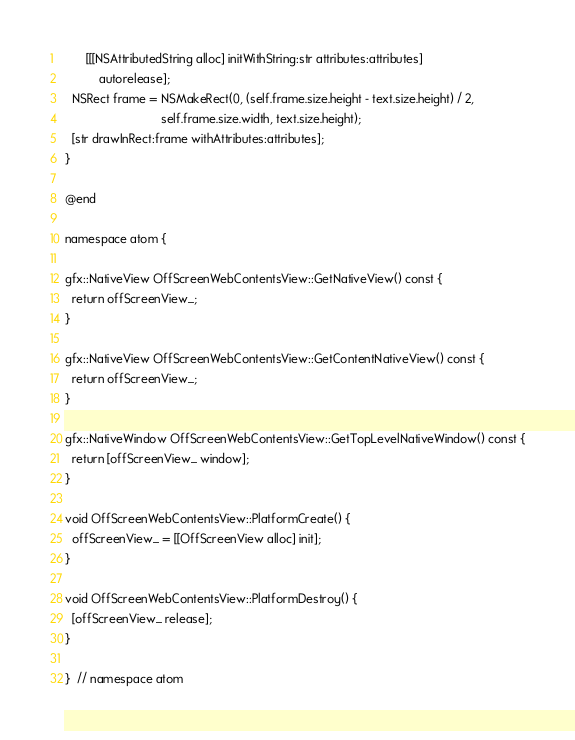Convert code to text. <code><loc_0><loc_0><loc_500><loc_500><_ObjectiveC_>      [[[NSAttributedString alloc] initWithString:str attributes:attributes]
          autorelease];
  NSRect frame = NSMakeRect(0, (self.frame.size.height - text.size.height) / 2,
                            self.frame.size.width, text.size.height);
  [str drawInRect:frame withAttributes:attributes];
}

@end

namespace atom {

gfx::NativeView OffScreenWebContentsView::GetNativeView() const {
  return offScreenView_;
}

gfx::NativeView OffScreenWebContentsView::GetContentNativeView() const {
  return offScreenView_;
}

gfx::NativeWindow OffScreenWebContentsView::GetTopLevelNativeWindow() const {
  return [offScreenView_ window];
}

void OffScreenWebContentsView::PlatformCreate() {
  offScreenView_ = [[OffScreenView alloc] init];
}

void OffScreenWebContentsView::PlatformDestroy() {
  [offScreenView_ release];
}

}  // namespace atom
</code> 